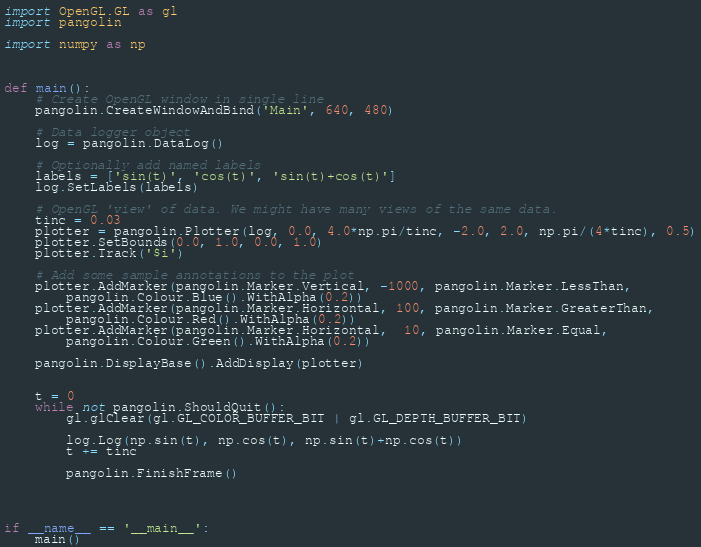<code> <loc_0><loc_0><loc_500><loc_500><_Python_>import OpenGL.GL as gl 
import pangolin

import numpy as np



def main():
    # Create OpenGL window in single line
    pangolin.CreateWindowAndBind('Main', 640, 480)

    # Data logger object
    log = pangolin.DataLog()

    # Optionally add named labels
    labels = ['sin(t)', 'cos(t)', 'sin(t)+cos(t)']
    log.SetLabels(labels)

    # OpenGL 'view' of data. We might have many views of the same data.
    tinc = 0.03
    plotter = pangolin.Plotter(log, 0.0, 4.0*np.pi/tinc, -2.0, 2.0, np.pi/(4*tinc), 0.5)
    plotter.SetBounds(0.0, 1.0, 0.0, 1.0)
    plotter.Track('$i')

    # Add some sample annotations to the plot
    plotter.AddMarker(pangolin.Marker.Vertical, -1000, pangolin.Marker.LessThan, 
        pangolin.Colour.Blue().WithAlpha(0.2))
    plotter.AddMarker(pangolin.Marker.Horizontal, 100, pangolin.Marker.GreaterThan, 
        pangolin.Colour.Red().WithAlpha(0.2))
    plotter.AddMarker(pangolin.Marker.Horizontal,  10, pangolin.Marker.Equal, 
        pangolin.Colour.Green().WithAlpha(0.2))

    pangolin.DisplayBase().AddDisplay(plotter)


    t = 0
    while not pangolin.ShouldQuit():
        gl.glClear(gl.GL_COLOR_BUFFER_BIT | gl.GL_DEPTH_BUFFER_BIT)

        log.Log(np.sin(t), np.cos(t), np.sin(t)+np.cos(t))
        t += tinc

        pangolin.FinishFrame()




if __name__ == '__main__':
    main()</code> 